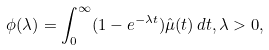<formula> <loc_0><loc_0><loc_500><loc_500>\phi ( \lambda ) = \int _ { 0 } ^ { \infty } ( 1 - e ^ { - \lambda t } ) \hat { \mu } ( t ) \, d t , \lambda > 0 ,</formula> 